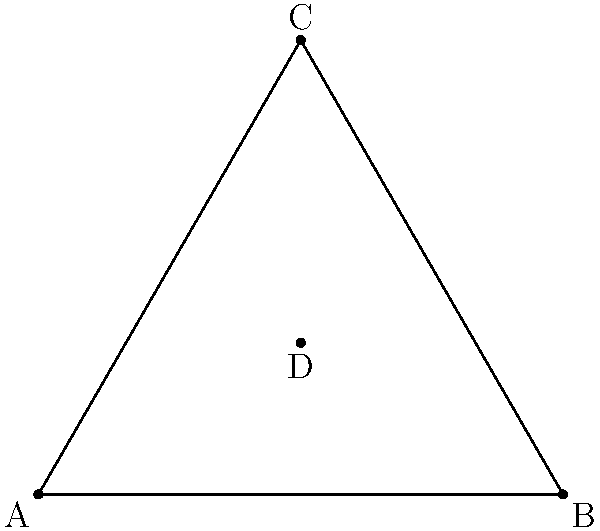As a military strategist, you're tasked with optimizing radar coverage for a triangular region representing a strategic area. The region is modeled by an equilateral triangle ABC with side length 10 units. If a radar station placed at the centroid D can cover a circular area with a radius of 5 units, what percentage of the triangular region's area is covered by the radar? Let's approach this step-by-step:

1) First, we need to calculate the area of the equilateral triangle ABC.
   The area of an equilateral triangle is given by: $A = \frac{\sqrt{3}}{4}a^2$
   Where $a$ is the side length.
   $A_{triangle} = \frac{\sqrt{3}}{4} * 10^2 = 25\sqrt{3}$ square units

2) Next, we need to calculate the area of the circular radar coverage.
   The area of a circle is given by: $A = \pi r^2$
   $A_{circle} = \pi * 5^2 = 25\pi$ square units

3) However, not all of this circular area is within the triangle. The radar coverage extends beyond the triangle's borders.

4) The centroid of an equilateral triangle divides each median in the ratio 2:1.
   This means that the distance from any vertex to the centroid is $\frac{2}{3}$ of the triangle's height.

5) The height of the triangle can be calculated as:
   $h = \frac{\sqrt{3}}{2}a = \frac{\sqrt{3}}{2} * 10 = 5\sqrt{3}$

6) The distance from any vertex to the centroid is therefore:
   $\frac{2}{3} * 5\sqrt{3} = \frac{10\sqrt{3}}{3} \approx 5.77$ units

7) Since this distance is greater than the radar's radius (5 units), the circular radar coverage fits entirely within the triangle.

8) Therefore, the percentage of the triangle's area covered by the radar is:
   $\frac{A_{circle}}{A_{triangle}} * 100\% = \frac{25\pi}{25\sqrt{3}} * 100\% = \frac{\pi}{\sqrt{3}} * 100\% \approx 181.73\%$
Answer: $\frac{\pi}{\sqrt{3}} * 100\%$ (approximately 181.73%) 